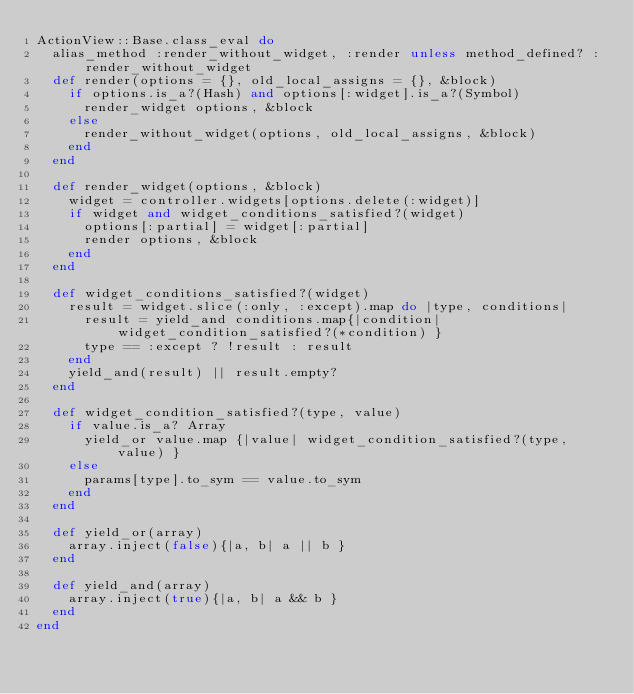<code> <loc_0><loc_0><loc_500><loc_500><_Ruby_>ActionView::Base.class_eval do
  alias_method :render_without_widget, :render unless method_defined? :render_without_widget
  def render(options = {}, old_local_assigns = {}, &block)
    if options.is_a?(Hash) and options[:widget].is_a?(Symbol)
      render_widget options, &block
    else
      render_without_widget(options, old_local_assigns, &block)
    end
  end
  
  def render_widget(options, &block)
    widget = controller.widgets[options.delete(:widget)]
    if widget and widget_conditions_satisfied?(widget)
      options[:partial] = widget[:partial]
      render options, &block
    end
  end
  
  def widget_conditions_satisfied?(widget)
    result = widget.slice(:only, :except).map do |type, conditions|
      result = yield_and conditions.map{|condition| widget_condition_satisfied?(*condition) }
      type == :except ? !result : result
    end
    yield_and(result) || result.empty?
  end
  
  def widget_condition_satisfied?(type, value)
    if value.is_a? Array
      yield_or value.map {|value| widget_condition_satisfied?(type, value) }
    else
      params[type].to_sym == value.to_sym
    end
  end  

  def yield_or(array)
    array.inject(false){|a, b| a || b }
  end
  
  def yield_and(array)
    array.inject(true){|a, b| a && b }
  end  
end</code> 